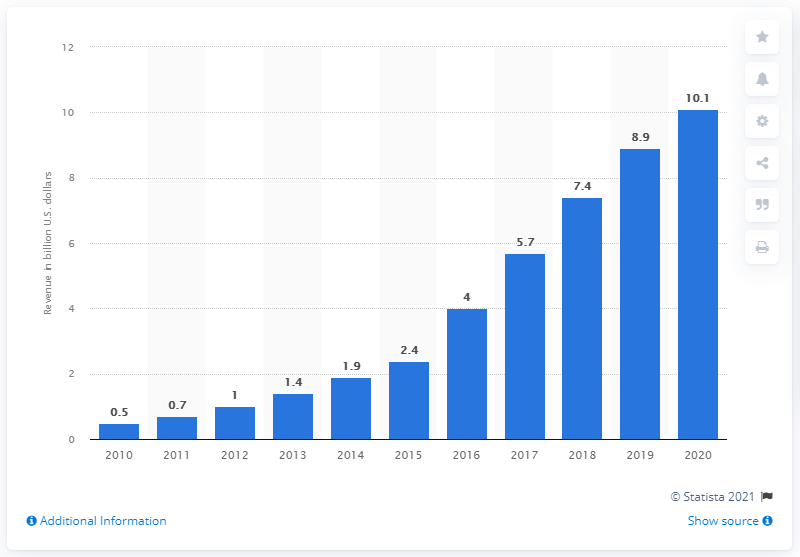Draw attention to some important aspects in this diagram. In 2014, the streaming revenue in the United States was 1.9 billion dollars. In 2020, streaming revenue in the U.S. was approximately 10.1 million dollars. 